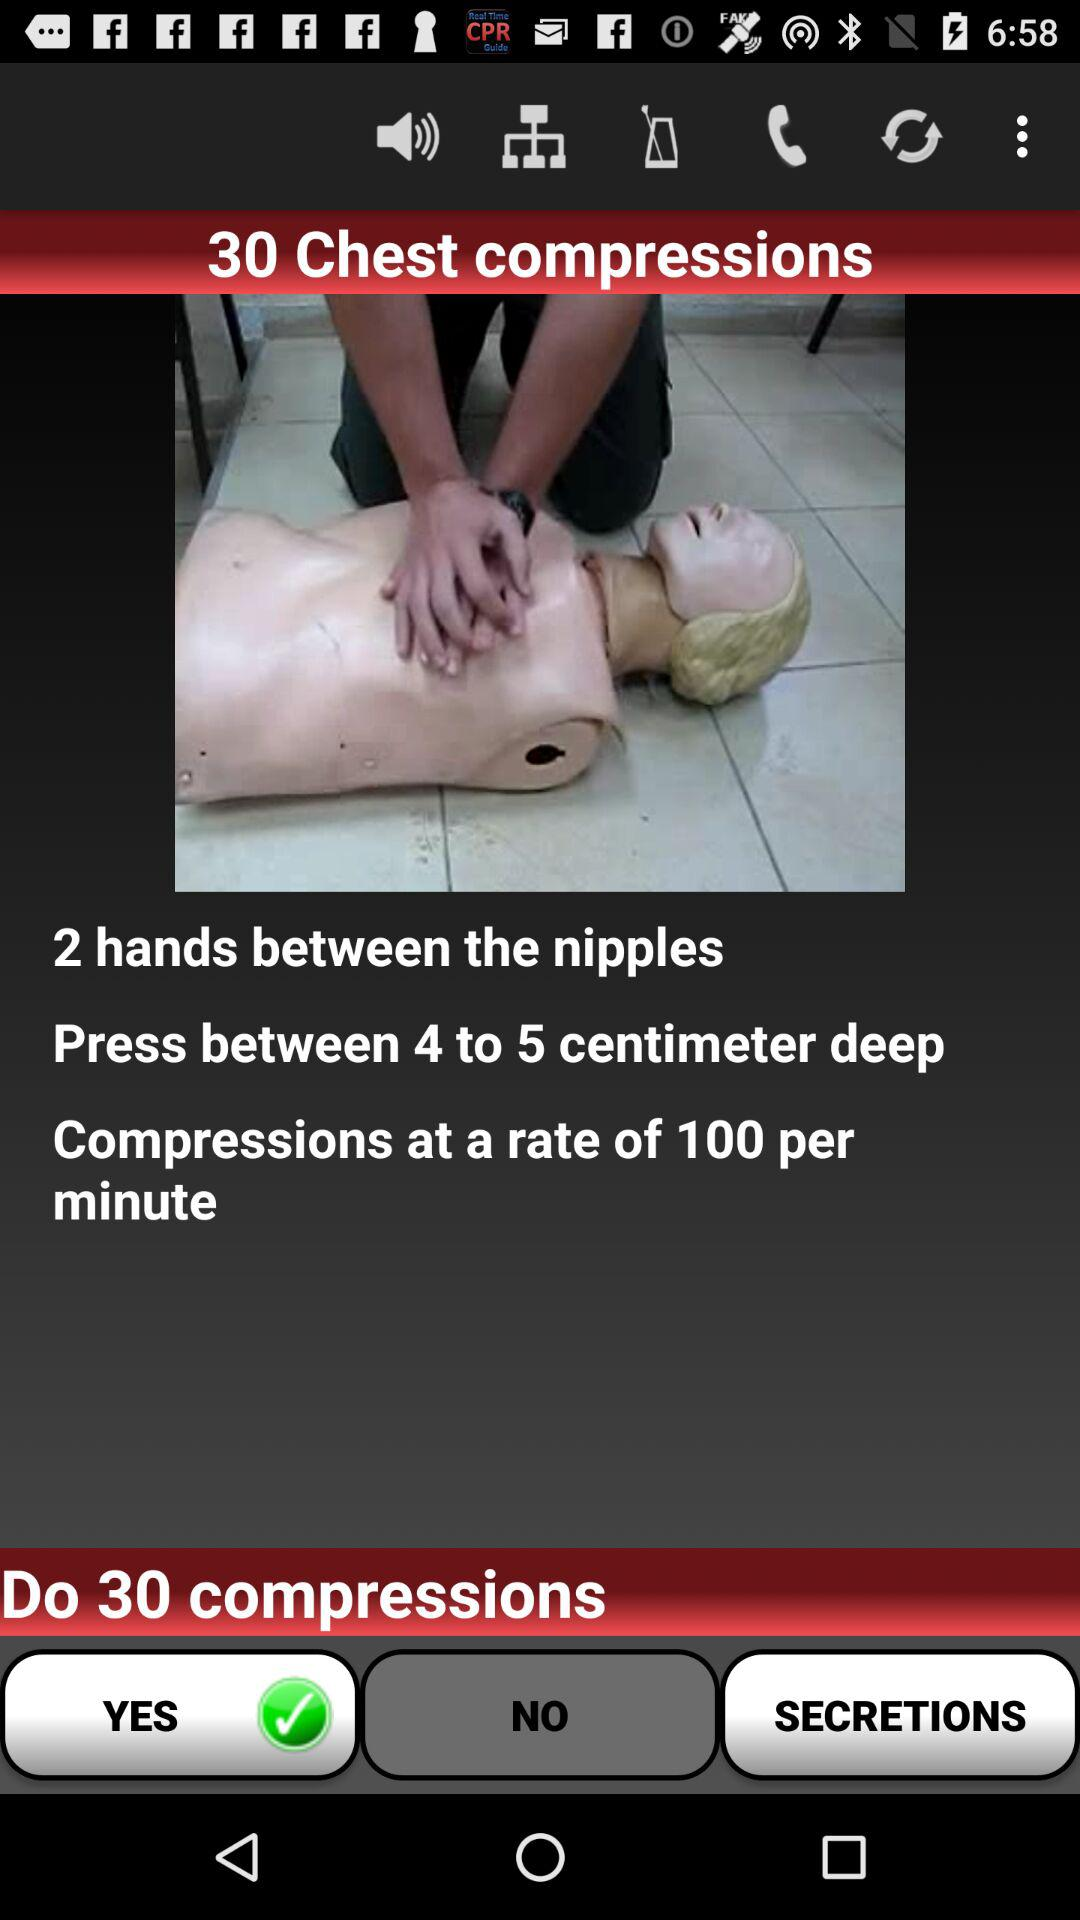How many compressions per minute are you supposed to do?
Answer the question using a single word or phrase. 100 